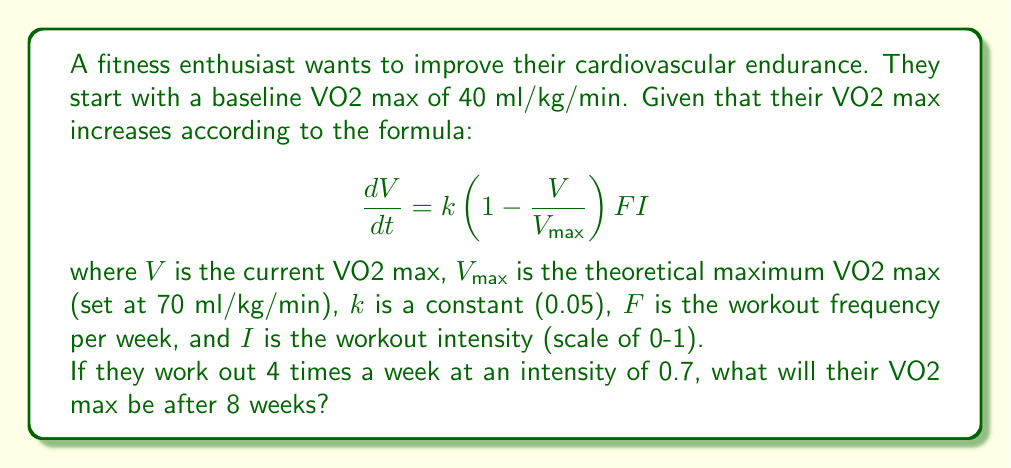Give your solution to this math problem. Let's approach this step-by-step:

1) We start with the given differential equation:

   $$\frac{dV}{dt} = k(1 - \frac{V}{V_{max}})FI$$

2) We know the following values:
   - Initial $V_0 = 40$ ml/kg/min
   - $V_{max} = 70$ ml/kg/min
   - $k = 0.05$
   - $F = 4$ times per week
   - $I = 0.7$
   - Time $t = 8$ weeks

3) This is a separable differential equation. Let's separate and integrate:

   $$\int_{V_0}^V \frac{dV}{1 - \frac{V}{V_{max}}} = kFI \int_0^t dt$$

4) Solving the left side:

   $$-V_{max} \ln|1 - \frac{V}{V_{max}}| \bigg|_{V_0}^V = kFIt$$

5) Substituting the values:

   $$-70 \ln|1 - \frac{V}{70}| + 70 \ln|1 - \frac{40}{70}| = 0.05 * 4 * 0.7 * 8$$

6) Simplify the right side:
   
   $$-70 \ln|1 - \frac{V}{70}| + 70 \ln(\frac{3}{7}) = 1.12$$

7) Solve for $V$:

   $$\ln|1 - \frac{V}{70}| = \ln(\frac{3}{7}) - \frac{1.12}{70}$$
   
   $$1 - \frac{V}{70} = \frac{3}{7} e^{-\frac{1.12}{70}}$$

   $$V = 70(1 - \frac{3}{7} e^{-\frac{1.12}{70}}) \approx 47.8$$

Therefore, after 8 weeks, their VO2 max will be approximately 47.8 ml/kg/min.
Answer: 47.8 ml/kg/min 